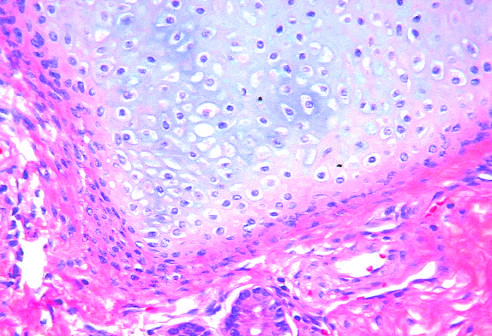do testicular teratomas contain mature cells from endodermal, mesodermal, and ectodermal lines?
Answer the question using a single word or phrase. Yes 